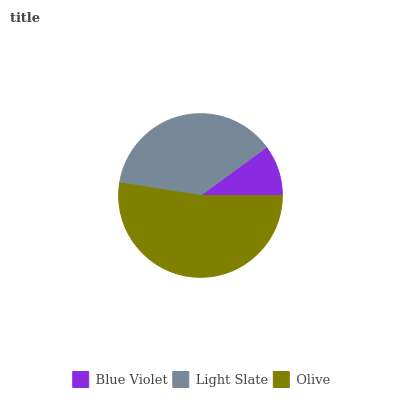Is Blue Violet the minimum?
Answer yes or no. Yes. Is Olive the maximum?
Answer yes or no. Yes. Is Light Slate the minimum?
Answer yes or no. No. Is Light Slate the maximum?
Answer yes or no. No. Is Light Slate greater than Blue Violet?
Answer yes or no. Yes. Is Blue Violet less than Light Slate?
Answer yes or no. Yes. Is Blue Violet greater than Light Slate?
Answer yes or no. No. Is Light Slate less than Blue Violet?
Answer yes or no. No. Is Light Slate the high median?
Answer yes or no. Yes. Is Light Slate the low median?
Answer yes or no. Yes. Is Blue Violet the high median?
Answer yes or no. No. Is Olive the low median?
Answer yes or no. No. 